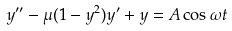<formula> <loc_0><loc_0><loc_500><loc_500>y ^ { \prime \prime } - \mu ( 1 - y ^ { 2 } ) y ^ { \prime } + y = A \cos \omega t</formula> 